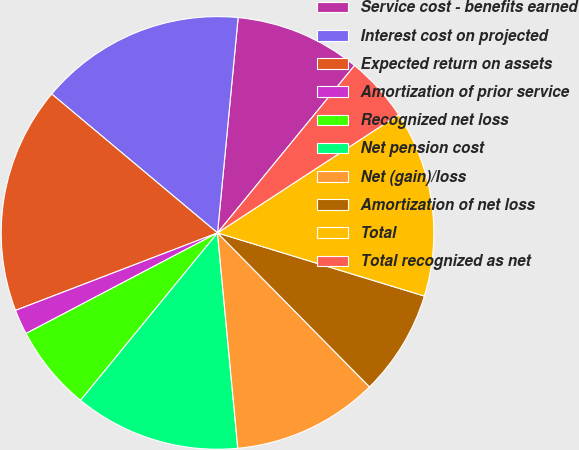Convert chart to OTSL. <chart><loc_0><loc_0><loc_500><loc_500><pie_chart><fcel>Service cost - benefits earned<fcel>Interest cost on projected<fcel>Expected return on assets<fcel>Amortization of prior service<fcel>Recognized net loss<fcel>Net pension cost<fcel>Net (gain)/loss<fcel>Amortization of net loss<fcel>Total<fcel>Total recognized as net<nl><fcel>9.4%<fcel>15.42%<fcel>16.93%<fcel>1.87%<fcel>6.39%<fcel>12.41%<fcel>10.9%<fcel>7.89%<fcel>13.92%<fcel>4.88%<nl></chart> 